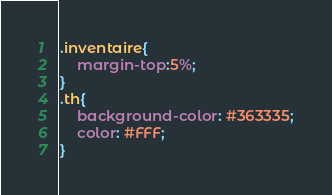Convert code to text. <code><loc_0><loc_0><loc_500><loc_500><_CSS_>.inventaire{
    margin-top:5%;
}
.th{
    background-color: #363335;
    color: #FFF;
}</code> 